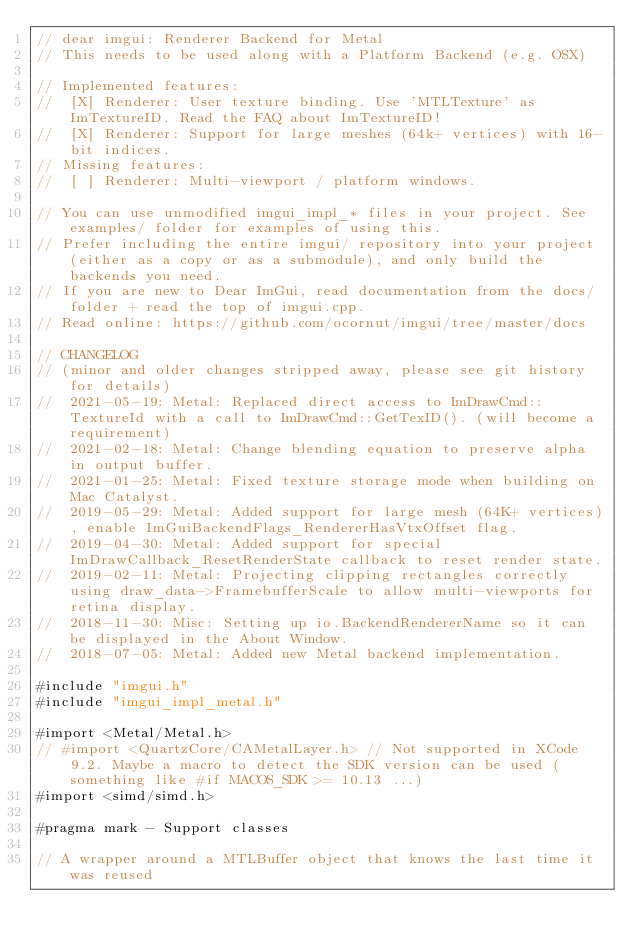Convert code to text. <code><loc_0><loc_0><loc_500><loc_500><_ObjectiveC_>// dear imgui: Renderer Backend for Metal
// This needs to be used along with a Platform Backend (e.g. OSX)

// Implemented features:
//  [X] Renderer: User texture binding. Use 'MTLTexture' as ImTextureID. Read the FAQ about ImTextureID!
//  [X] Renderer: Support for large meshes (64k+ vertices) with 16-bit indices.
// Missing features:
//  [ ] Renderer: Multi-viewport / platform windows.

// You can use unmodified imgui_impl_* files in your project. See examples/ folder for examples of using this. 
// Prefer including the entire imgui/ repository into your project (either as a copy or as a submodule), and only build the backends you need.
// If you are new to Dear ImGui, read documentation from the docs/ folder + read the top of imgui.cpp.
// Read online: https://github.com/ocornut/imgui/tree/master/docs

// CHANGELOG
// (minor and older changes stripped away, please see git history for details)
//  2021-05-19: Metal: Replaced direct access to ImDrawCmd::TextureId with a call to ImDrawCmd::GetTexID(). (will become a requirement)
//  2021-02-18: Metal: Change blending equation to preserve alpha in output buffer.
//  2021-01-25: Metal: Fixed texture storage mode when building on Mac Catalyst.
//  2019-05-29: Metal: Added support for large mesh (64K+ vertices), enable ImGuiBackendFlags_RendererHasVtxOffset flag.
//  2019-04-30: Metal: Added support for special ImDrawCallback_ResetRenderState callback to reset render state.
//  2019-02-11: Metal: Projecting clipping rectangles correctly using draw_data->FramebufferScale to allow multi-viewports for retina display.
//  2018-11-30: Misc: Setting up io.BackendRendererName so it can be displayed in the About Window.
//  2018-07-05: Metal: Added new Metal backend implementation.

#include "imgui.h"
#include "imgui_impl_metal.h"

#import <Metal/Metal.h>
// #import <QuartzCore/CAMetalLayer.h> // Not supported in XCode 9.2. Maybe a macro to detect the SDK version can be used (something like #if MACOS_SDK >= 10.13 ...)
#import <simd/simd.h>

#pragma mark - Support classes

// A wrapper around a MTLBuffer object that knows the last time it was reused</code> 